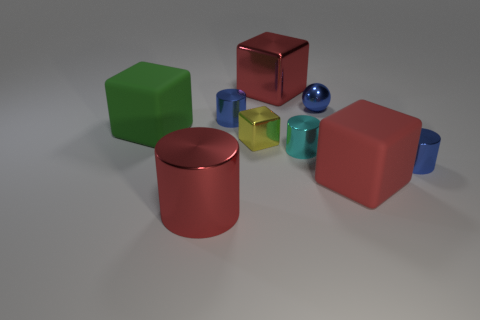The green block is what size? The green block appears to be mid-sized in comparison to other objects in the image. While it's not the smallest item depicted, it's visibly smaller than the largest blocks surrounding it. 